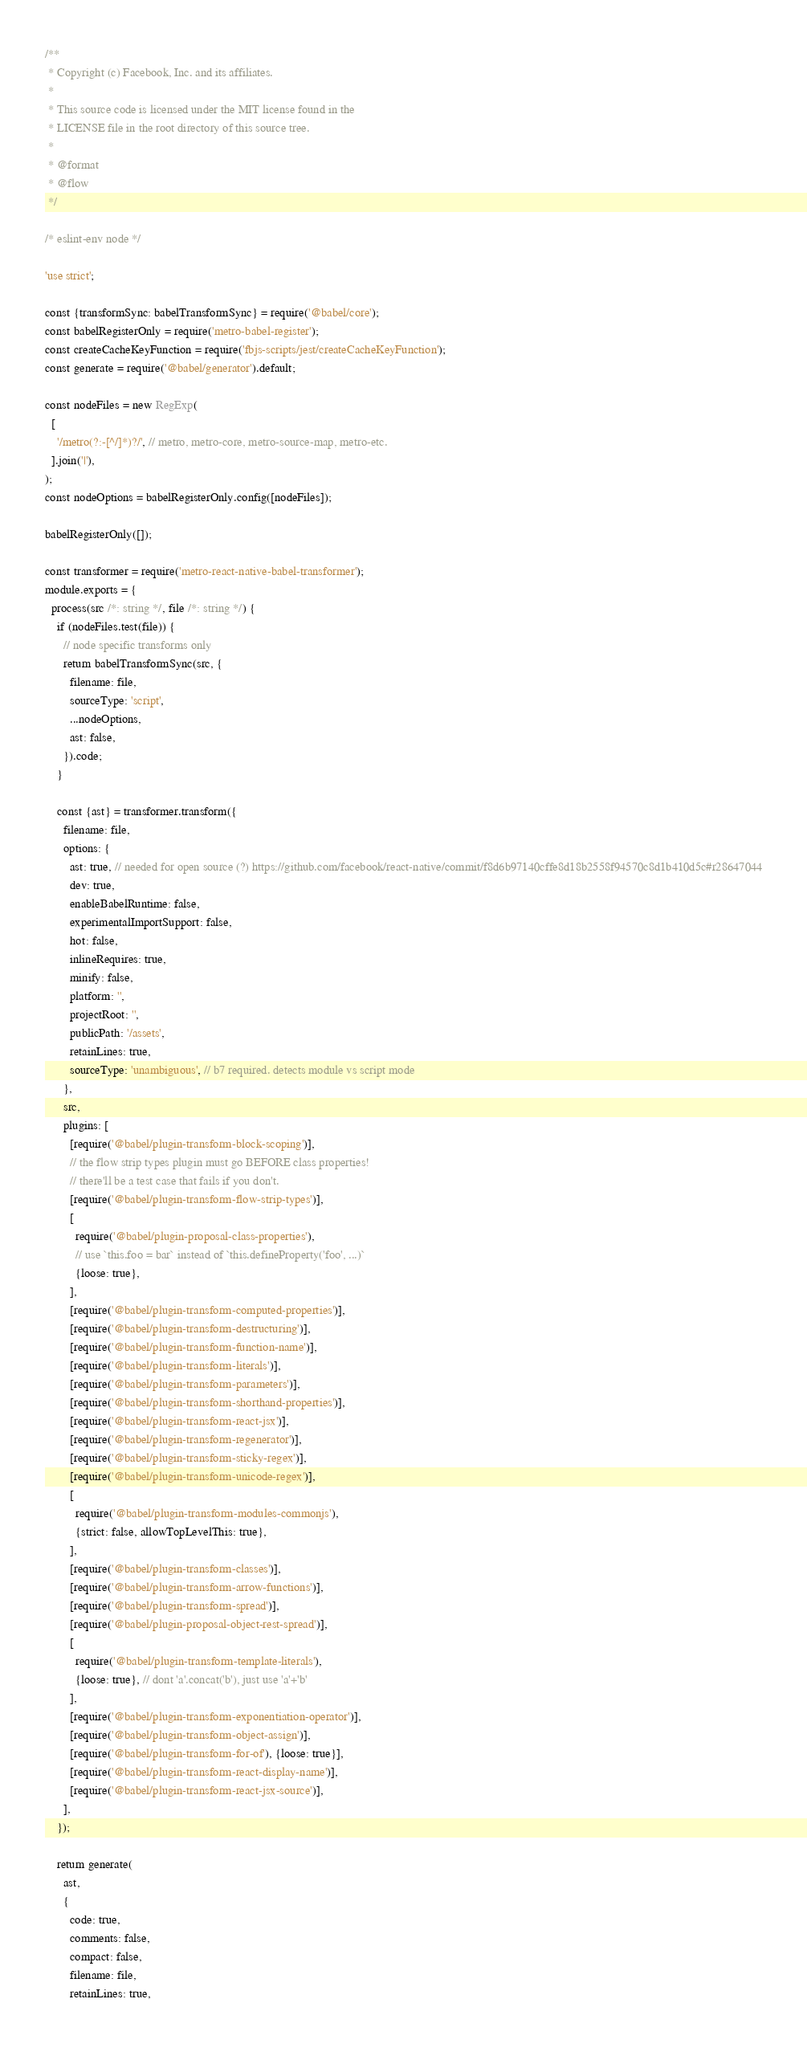<code> <loc_0><loc_0><loc_500><loc_500><_JavaScript_>/**
 * Copyright (c) Facebook, Inc. and its affiliates.
 *
 * This source code is licensed under the MIT license found in the
 * LICENSE file in the root directory of this source tree.
 *
 * @format
 * @flow
 */

/* eslint-env node */

'use strict';

const {transformSync: babelTransformSync} = require('@babel/core');
const babelRegisterOnly = require('metro-babel-register');
const createCacheKeyFunction = require('fbjs-scripts/jest/createCacheKeyFunction');
const generate = require('@babel/generator').default;

const nodeFiles = new RegExp(
  [
    '/metro(?:-[^/]*)?/', // metro, metro-core, metro-source-map, metro-etc.
  ].join('|'),
);
const nodeOptions = babelRegisterOnly.config([nodeFiles]);

babelRegisterOnly([]);

const transformer = require('metro-react-native-babel-transformer');
module.exports = {
  process(src /*: string */, file /*: string */) {
    if (nodeFiles.test(file)) {
      // node specific transforms only
      return babelTransformSync(src, {
        filename: file,
        sourceType: 'script',
        ...nodeOptions,
        ast: false,
      }).code;
    }

    const {ast} = transformer.transform({
      filename: file,
      options: {
        ast: true, // needed for open source (?) https://github.com/facebook/react-native/commit/f8d6b97140cffe8d18b2558f94570c8d1b410d5c#r28647044
        dev: true,
        enableBabelRuntime: false,
        experimentalImportSupport: false,
        hot: false,
        inlineRequires: true,
        minify: false,
        platform: '',
        projectRoot: '',
        publicPath: '/assets',
        retainLines: true,
        sourceType: 'unambiguous', // b7 required. detects module vs script mode
      },
      src,
      plugins: [
        [require('@babel/plugin-transform-block-scoping')],
        // the flow strip types plugin must go BEFORE class properties!
        // there'll be a test case that fails if you don't.
        [require('@babel/plugin-transform-flow-strip-types')],
        [
          require('@babel/plugin-proposal-class-properties'),
          // use `this.foo = bar` instead of `this.defineProperty('foo', ...)`
          {loose: true},
        ],
        [require('@babel/plugin-transform-computed-properties')],
        [require('@babel/plugin-transform-destructuring')],
        [require('@babel/plugin-transform-function-name')],
        [require('@babel/plugin-transform-literals')],
        [require('@babel/plugin-transform-parameters')],
        [require('@babel/plugin-transform-shorthand-properties')],
        [require('@babel/plugin-transform-react-jsx')],
        [require('@babel/plugin-transform-regenerator')],
        [require('@babel/plugin-transform-sticky-regex')],
        [require('@babel/plugin-transform-unicode-regex')],
        [
          require('@babel/plugin-transform-modules-commonjs'),
          {strict: false, allowTopLevelThis: true},
        ],
        [require('@babel/plugin-transform-classes')],
        [require('@babel/plugin-transform-arrow-functions')],
        [require('@babel/plugin-transform-spread')],
        [require('@babel/plugin-proposal-object-rest-spread')],
        [
          require('@babel/plugin-transform-template-literals'),
          {loose: true}, // dont 'a'.concat('b'), just use 'a'+'b'
        ],
        [require('@babel/plugin-transform-exponentiation-operator')],
        [require('@babel/plugin-transform-object-assign')],
        [require('@babel/plugin-transform-for-of'), {loose: true}],
        [require('@babel/plugin-transform-react-display-name')],
        [require('@babel/plugin-transform-react-jsx-source')],
      ],
    });

    return generate(
      ast,
      {
        code: true,
        comments: false,
        compact: false,
        filename: file,
        retainLines: true,</code> 